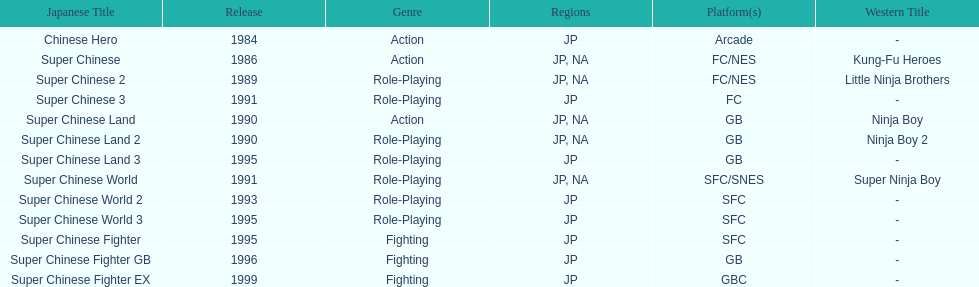How many super chinese international games were released 3. 